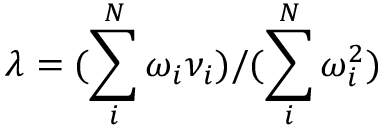Convert formula to latex. <formula><loc_0><loc_0><loc_500><loc_500>\lambda = ( \sum _ { i } ^ { N } \omega _ { i } \nu _ { i } ) / ( \sum _ { i } ^ { N } \omega _ { i } ^ { 2 } )</formula> 